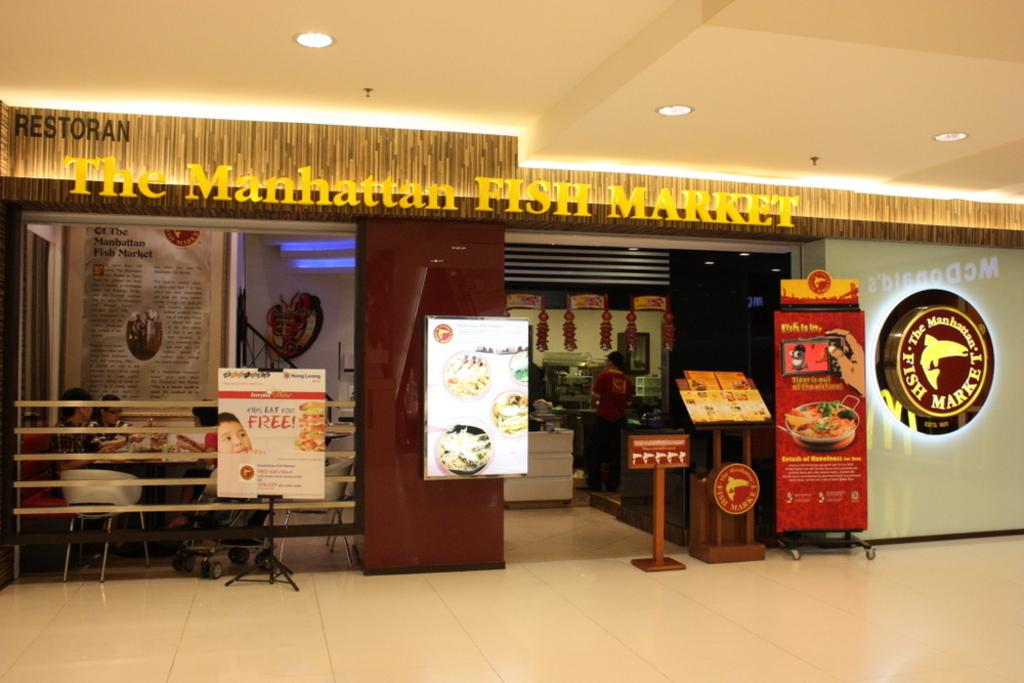<image>
Give a short and clear explanation of the subsequent image. entrance to the restaurant the manhattan fish market with several ads outside. 